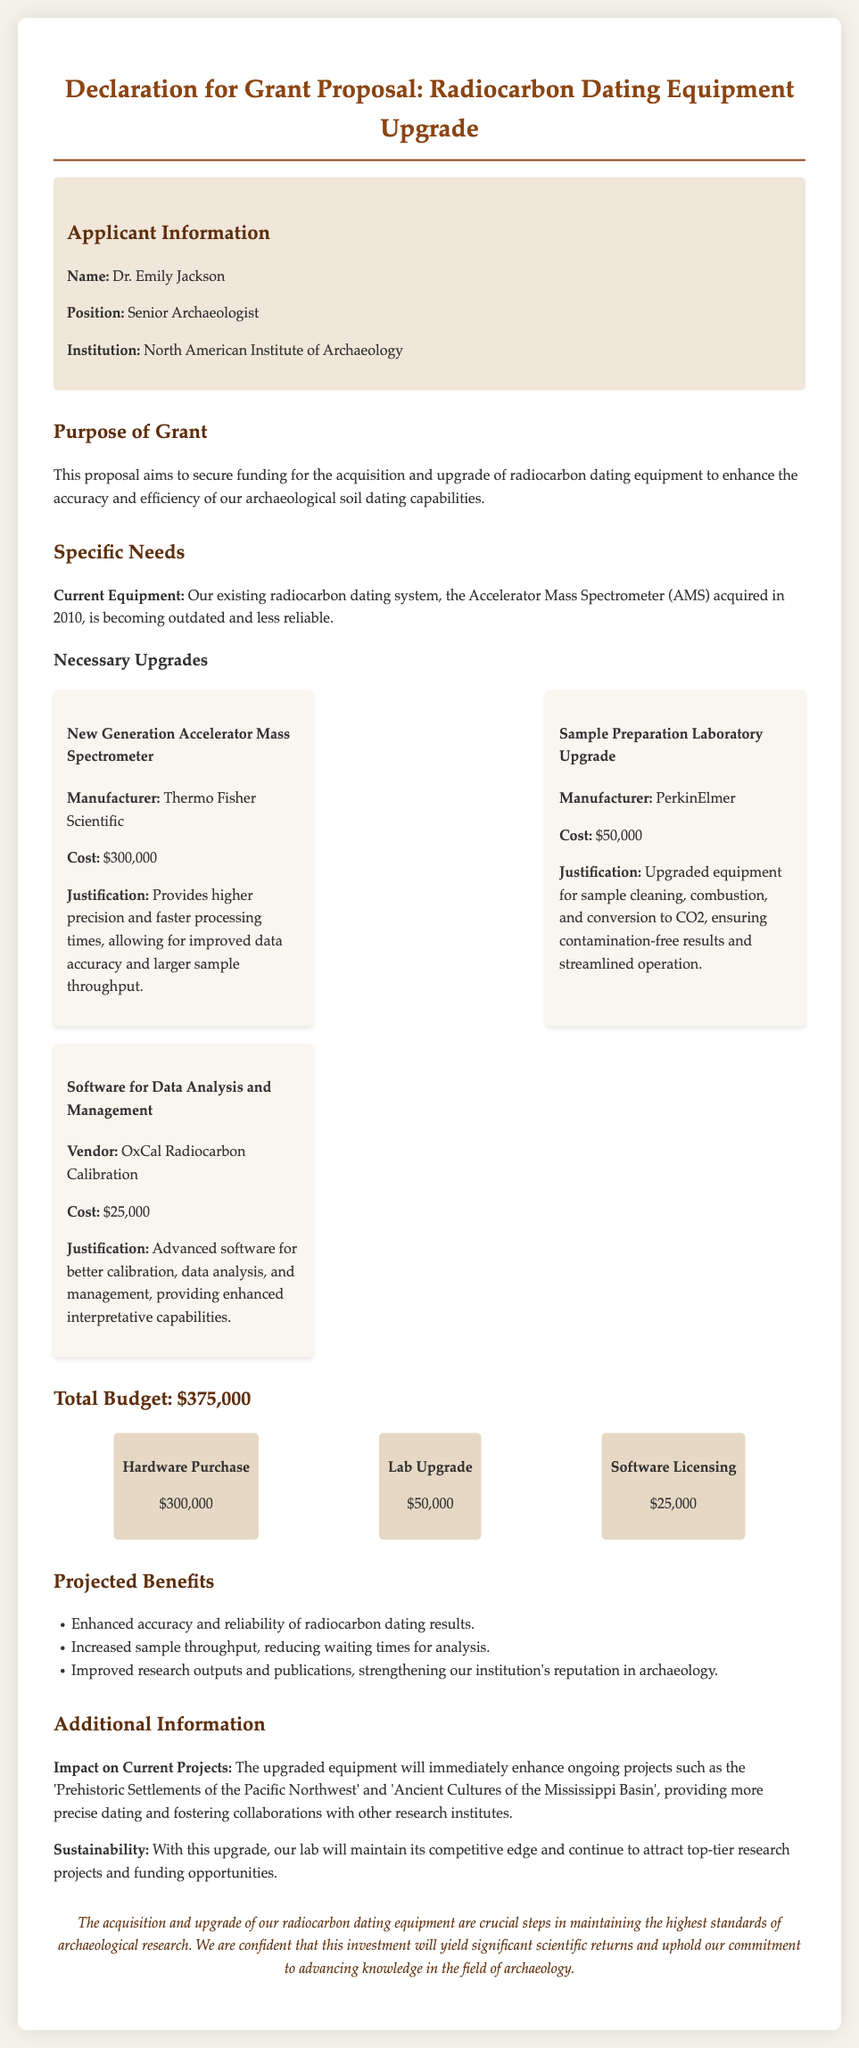What is the name of the applicant? The name is explicitly provided in the document under the applicant information section.
Answer: Dr. Emily Jackson What is the cost of the New Generation Accelerator Mass Spectrometer? The cost for this equipment is mentioned clearly in the specific needs section.
Answer: $300,000 What position does the applicant hold? The applicant's position is listed in the applicant information section.
Answer: Senior Archaeologist What is the total budget requested for the grant proposal? The total budget is summarized in the budget allocation section of the document.
Answer: $375,000 What is one of the ongoing projects that will benefit from the upgraded equipment? The document lists ongoing projects that will benefit from the new equipment.
Answer: Prehistoric Settlements of the Pacific Northwest What is the justification for the Sample Preparation Laboratory Upgrade? The justification provides reasoning for the need for this specific upgrade in the document.
Answer: Ensuring contamination-free results and streamlined operation How much funding is allocated for software licensing? The budget allocation clearly specifies the amount set aside for software licensing in the document.
Answer: $25,000 What will improved accuracy and reliability of radiocarbon dating results enhance? This relates to the projected benefits listed in the document which explains the positive impacts.
Answer: Research outputs and publications What manufacturer is associated with the Sample Preparation Laboratory Upgrade? The manufacturer name is specified in the equipment list within the proposal.
Answer: PerkinElmer 